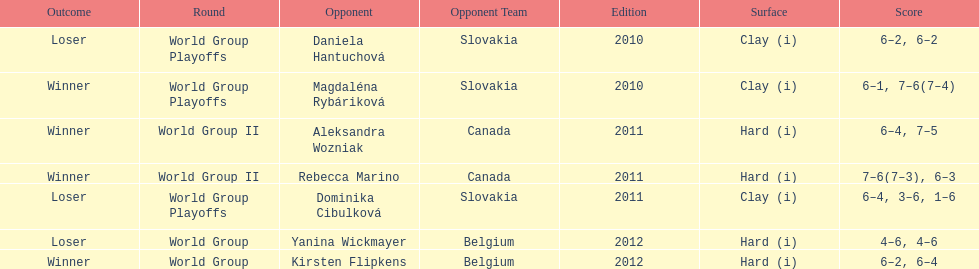Did they beat canada in more or less than 3 matches? Less. 